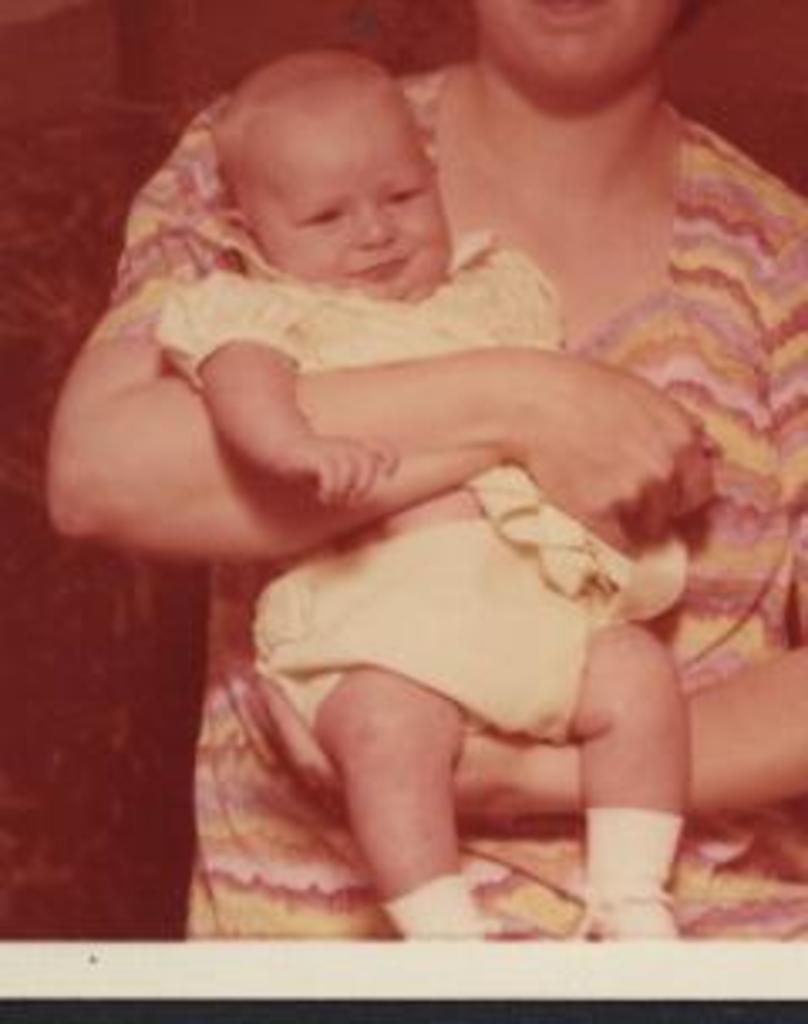Please provide a concise description of this image. In the center of the image we can see woman carrying a baby. 